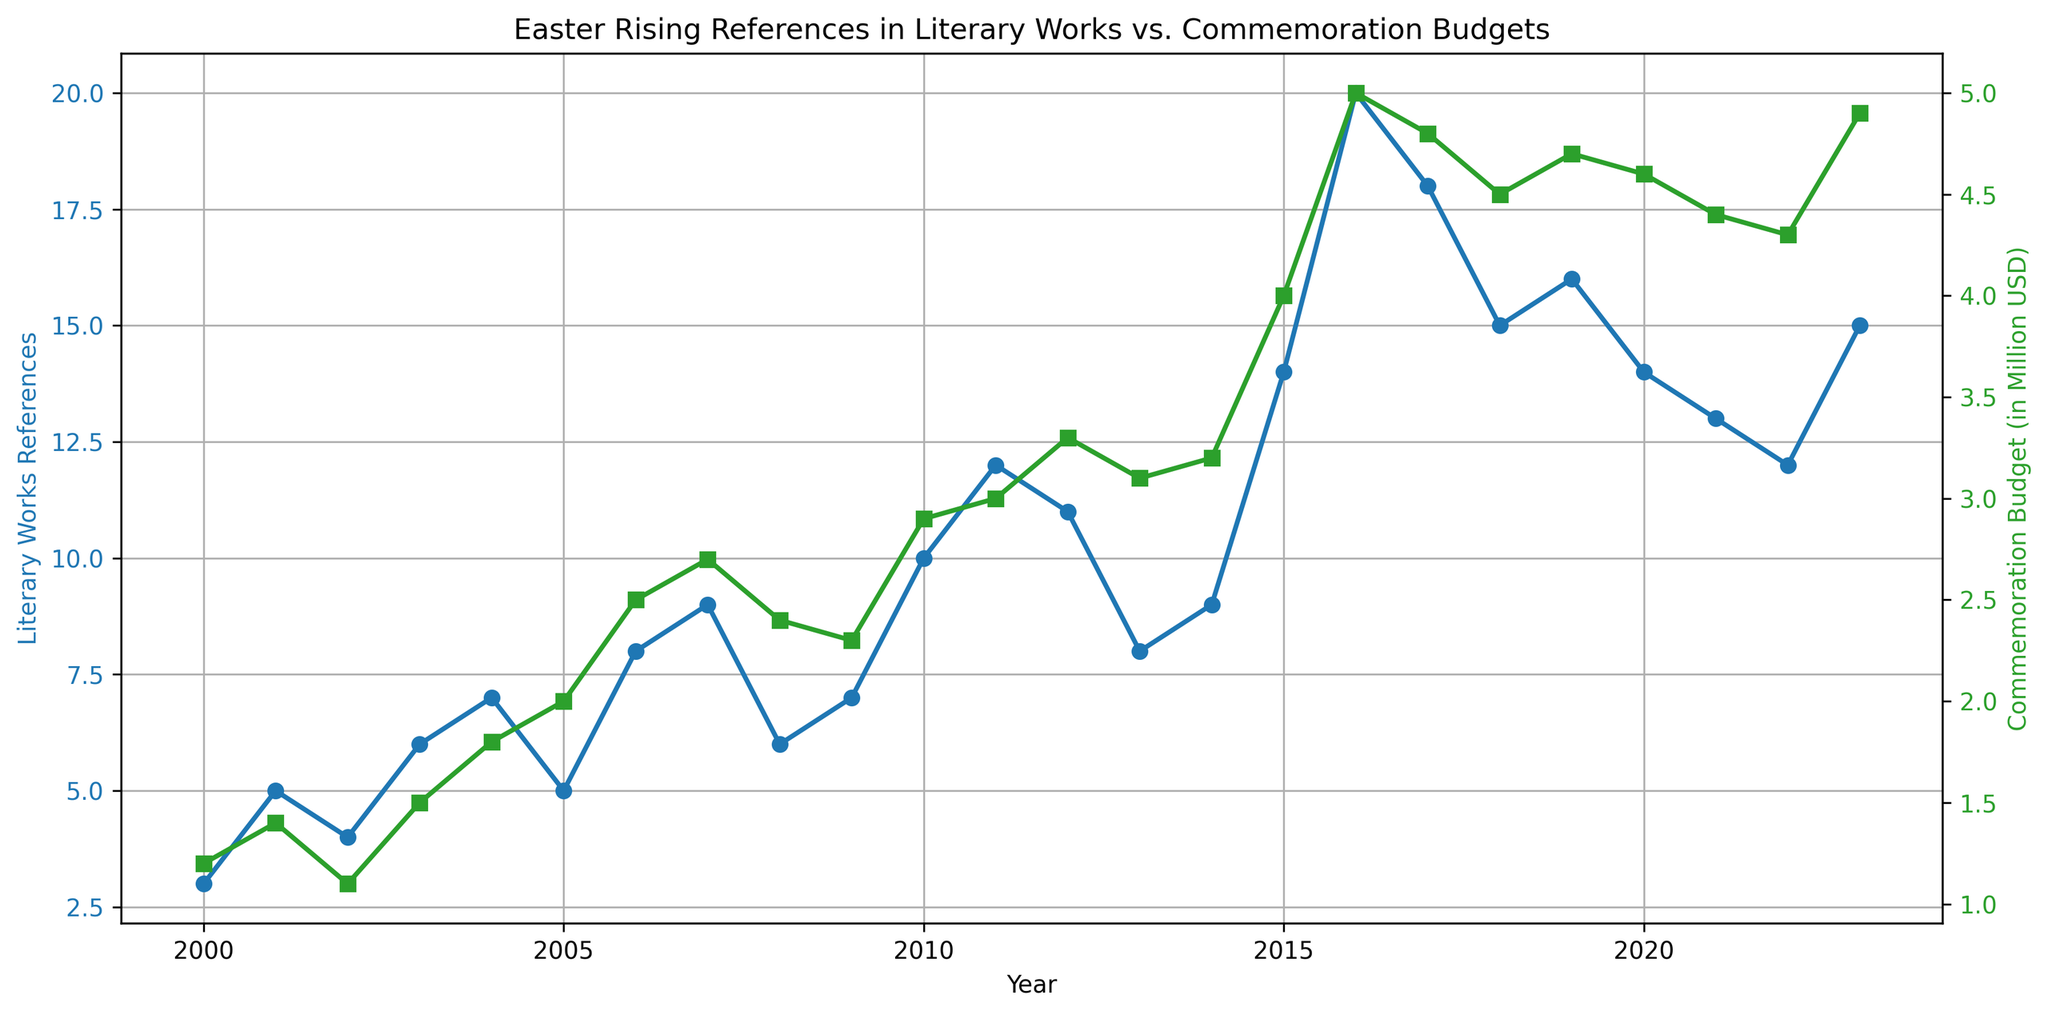What was the trend of the number of literary works referencing the Easter Rising from 2000 to 2023? Observing the blue line and its markers (circles) from 2000 to 2023, we see an upward trend with fluctuations. It started from 3 in 2000 and peaked at 20 in 2016 before slightly decreasing and then fluctuating in later years, ending at 15 in 2023.
Answer: Upwards with fluctuations In which year did the commemoration budget reach its highest point, and how much was it? The green line and its markers (squares) show that the budget reached its highest point in 2016 with 5 million USD.
Answer: 2016, 5 million USD What is the difference in the number of literary works referencing the Easter Rising between 2016 and 2000? In 2016, there were 20 literary works referencing the Easter Rising, while in 2000, there were 3. The difference is 20 - 3 = 17.
Answer: 17 How does the number of literary works referencing the Easter Rising in 2016 compare to the number in 2022? In 2016, there were 20 literary works referencing the Easter Rising, and in 2022, there were 12. The 2016 number is greater than the 2022 number.
Answer: Greater in 2016 What color represents the commemoration budget line, and what is its shape? The commemoration budget line is represented by a green color and marker squares.
Answer: Green, squares Between which two consecutive years did the number of literary works referencing the Easter Rising increase the most? Comparing the differences year by year of the blue line, the largest increase happened between 2015 (14) and 2016 (20), which is an increase of 6.
Answer: 2015 to 2016 Calculate the average number of literary works referencing the Easter Rising over the first ten years (2000-2009). Summing the number of literary works from 2000 to 2009: 3 + 5 + 4 + 6 + 7 + 5 + 8 + 9 + 6 + 7 = 60, and there are 10 years. The average is 60/10 = 6.
Answer: 6 Is there any year when the number of literary works referencing the Easter Rising and the commemoration budget are visually at their maximum? Yes, in 2016, both the number of literary works referencing the Easter Rising (20) and the commemoration budget (5 million USD) are at their highest values.
Answer: Yes Compare the visual patterns of the literary works referencing Easter Rising and the commemoration budget lines. Are they continuously increasing, decreasing, or fluctuating? Both lines show fluctuations. The literary works referencing Easter Rising generally increase but fluctuate over some periods, while the commemoration budget consistently rises from 2000 to 2016 and then fluctuates slightly.
Answer: Fluctuating 